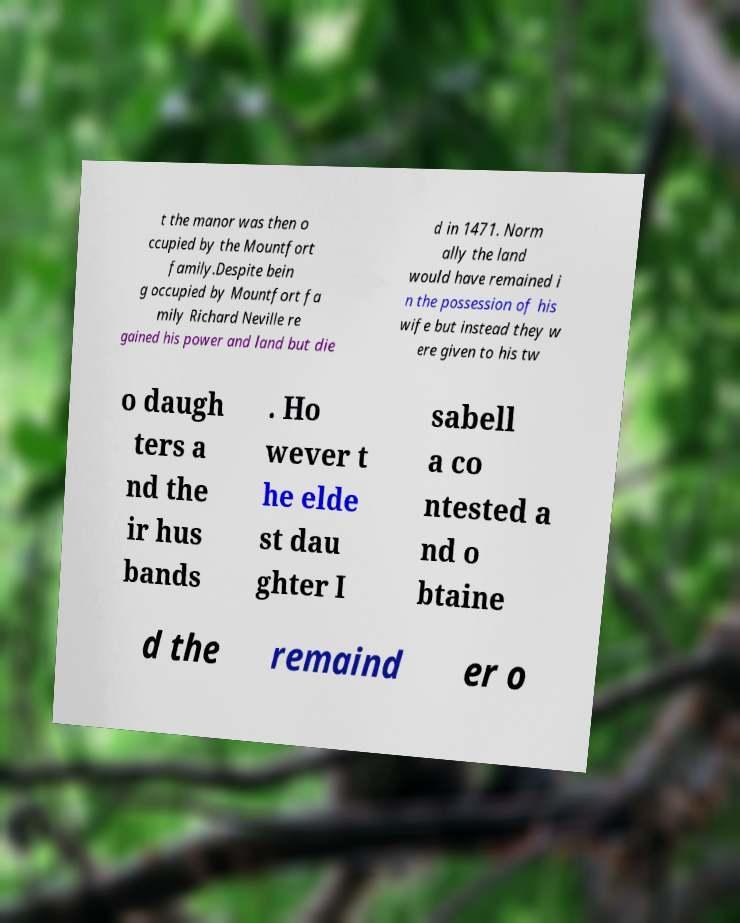There's text embedded in this image that I need extracted. Can you transcribe it verbatim? t the manor was then o ccupied by the Mountfort family.Despite bein g occupied by Mountfort fa mily Richard Neville re gained his power and land but die d in 1471. Norm ally the land would have remained i n the possession of his wife but instead they w ere given to his tw o daugh ters a nd the ir hus bands . Ho wever t he elde st dau ghter I sabell a co ntested a nd o btaine d the remaind er o 